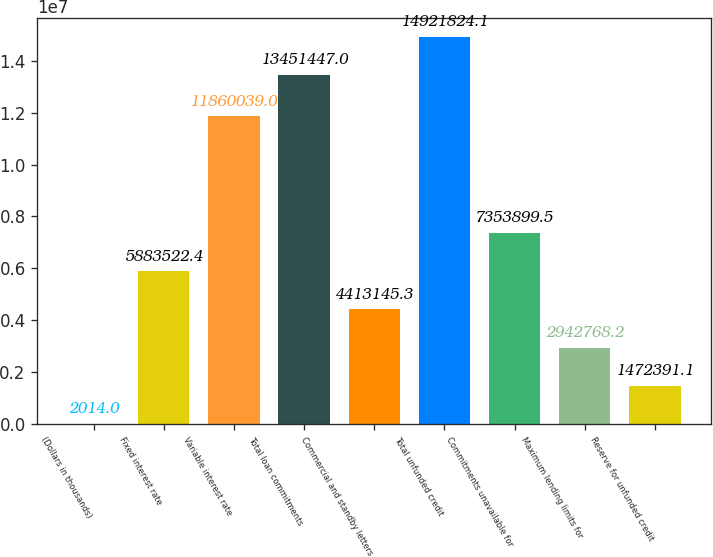Convert chart. <chart><loc_0><loc_0><loc_500><loc_500><bar_chart><fcel>(Dollars in thousands)<fcel>Fixed interest rate<fcel>Variable interest rate<fcel>Total loan commitments<fcel>Commercial and standby letters<fcel>Total unfunded credit<fcel>Commitments unavailable for<fcel>Maximum lending limits for<fcel>Reserve for unfunded credit<nl><fcel>2014<fcel>5.88352e+06<fcel>1.186e+07<fcel>1.34514e+07<fcel>4.41315e+06<fcel>1.49218e+07<fcel>7.3539e+06<fcel>2.94277e+06<fcel>1.47239e+06<nl></chart> 